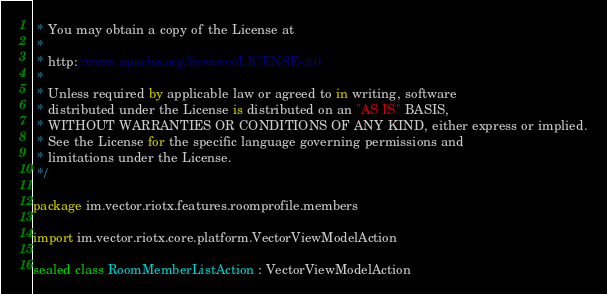<code> <loc_0><loc_0><loc_500><loc_500><_Kotlin_> * You may obtain a copy of the License at
 *
 * http://www.apache.org/licenses/LICENSE-2.0
 *
 * Unless required by applicable law or agreed to in writing, software
 * distributed under the License is distributed on an "AS IS" BASIS,
 * WITHOUT WARRANTIES OR CONDITIONS OF ANY KIND, either express or implied.
 * See the License for the specific language governing permissions and
 * limitations under the License.
 */

package im.vector.riotx.features.roomprofile.members

import im.vector.riotx.core.platform.VectorViewModelAction

sealed class RoomMemberListAction : VectorViewModelAction
</code> 